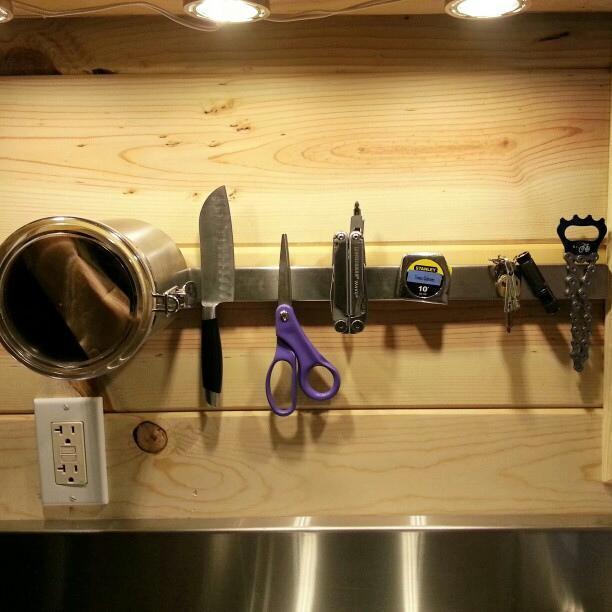How many knives are on the wall?
Give a very brief answer. 1. 